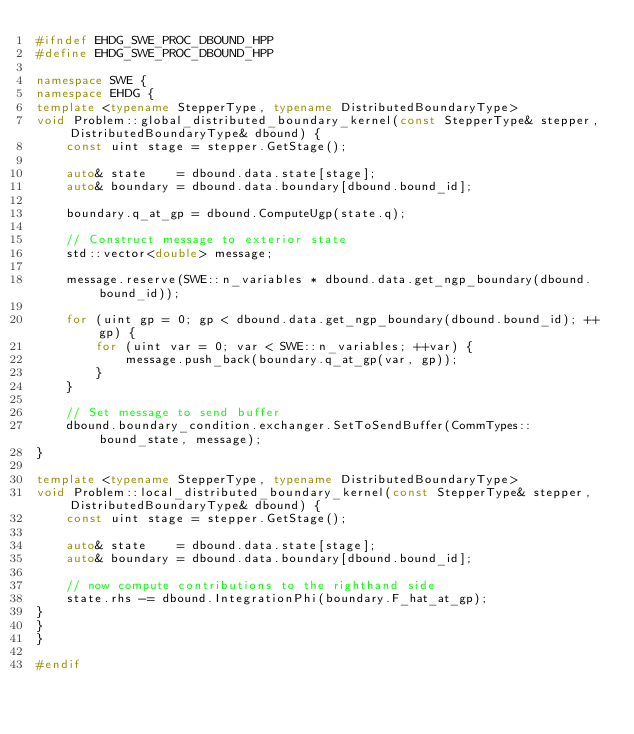<code> <loc_0><loc_0><loc_500><loc_500><_C++_>#ifndef EHDG_SWE_PROC_DBOUND_HPP
#define EHDG_SWE_PROC_DBOUND_HPP

namespace SWE {
namespace EHDG {
template <typename StepperType, typename DistributedBoundaryType>
void Problem::global_distributed_boundary_kernel(const StepperType& stepper, DistributedBoundaryType& dbound) {
    const uint stage = stepper.GetStage();

    auto& state    = dbound.data.state[stage];
    auto& boundary = dbound.data.boundary[dbound.bound_id];

    boundary.q_at_gp = dbound.ComputeUgp(state.q);

    // Construct message to exterior state
    std::vector<double> message;

    message.reserve(SWE::n_variables * dbound.data.get_ngp_boundary(dbound.bound_id));

    for (uint gp = 0; gp < dbound.data.get_ngp_boundary(dbound.bound_id); ++gp) {
        for (uint var = 0; var < SWE::n_variables; ++var) {
            message.push_back(boundary.q_at_gp(var, gp));
        }
    }

    // Set message to send buffer
    dbound.boundary_condition.exchanger.SetToSendBuffer(CommTypes::bound_state, message);
}

template <typename StepperType, typename DistributedBoundaryType>
void Problem::local_distributed_boundary_kernel(const StepperType& stepper, DistributedBoundaryType& dbound) {
    const uint stage = stepper.GetStage();

    auto& state    = dbound.data.state[stage];
    auto& boundary = dbound.data.boundary[dbound.bound_id];

    // now compute contributions to the righthand side
    state.rhs -= dbound.IntegrationPhi(boundary.F_hat_at_gp);
}
}
}

#endif
</code> 